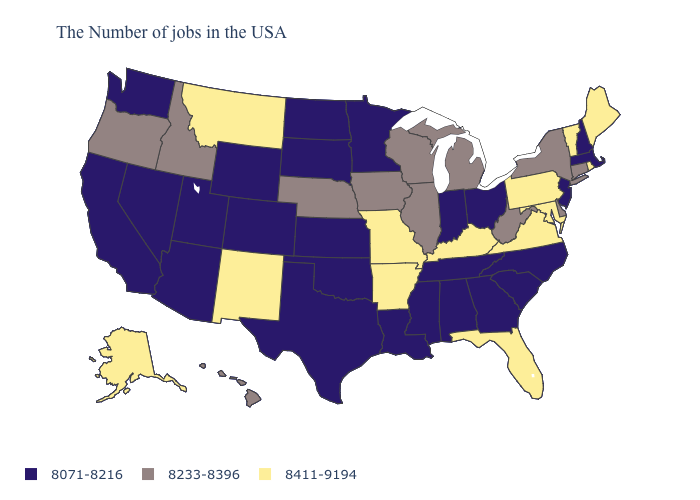Name the states that have a value in the range 8411-9194?
Concise answer only. Maine, Rhode Island, Vermont, Maryland, Pennsylvania, Virginia, Florida, Kentucky, Missouri, Arkansas, New Mexico, Montana, Alaska. What is the lowest value in the MidWest?
Be succinct. 8071-8216. What is the value of Oregon?
Short answer required. 8233-8396. Name the states that have a value in the range 8071-8216?
Be succinct. Massachusetts, New Hampshire, New Jersey, North Carolina, South Carolina, Ohio, Georgia, Indiana, Alabama, Tennessee, Mississippi, Louisiana, Minnesota, Kansas, Oklahoma, Texas, South Dakota, North Dakota, Wyoming, Colorado, Utah, Arizona, Nevada, California, Washington. What is the highest value in the West ?
Answer briefly. 8411-9194. What is the value of Alaska?
Write a very short answer. 8411-9194. Name the states that have a value in the range 8233-8396?
Give a very brief answer. Connecticut, New York, Delaware, West Virginia, Michigan, Wisconsin, Illinois, Iowa, Nebraska, Idaho, Oregon, Hawaii. Name the states that have a value in the range 8071-8216?
Quick response, please. Massachusetts, New Hampshire, New Jersey, North Carolina, South Carolina, Ohio, Georgia, Indiana, Alabama, Tennessee, Mississippi, Louisiana, Minnesota, Kansas, Oklahoma, Texas, South Dakota, North Dakota, Wyoming, Colorado, Utah, Arizona, Nevada, California, Washington. Among the states that border Illinois , does Missouri have the lowest value?
Concise answer only. No. Does the map have missing data?
Keep it brief. No. Which states hav the highest value in the MidWest?
Give a very brief answer. Missouri. What is the value of Colorado?
Keep it brief. 8071-8216. Does Nebraska have a higher value than Vermont?
Give a very brief answer. No. Is the legend a continuous bar?
Be succinct. No. 